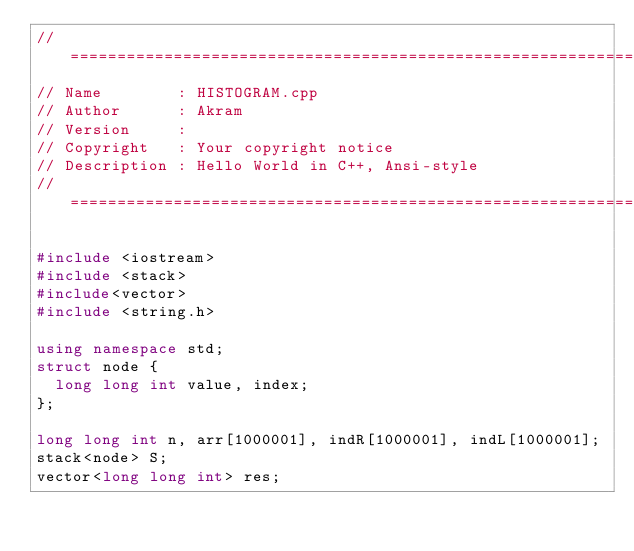<code> <loc_0><loc_0><loc_500><loc_500><_C++_>//============================================================================
// Name        : HISTOGRAM.cpp
// Author      : Akram
// Version     :
// Copyright   : Your copyright notice
// Description : Hello World in C++, Ansi-style
//============================================================================

#include <iostream>
#include <stack>
#include<vector>
#include <string.h>

using namespace std;
struct node {
	long long int value, index;
};

long long int n, arr[1000001], indR[1000001], indL[1000001];
stack<node> S;
vector<long long int> res;
</code> 